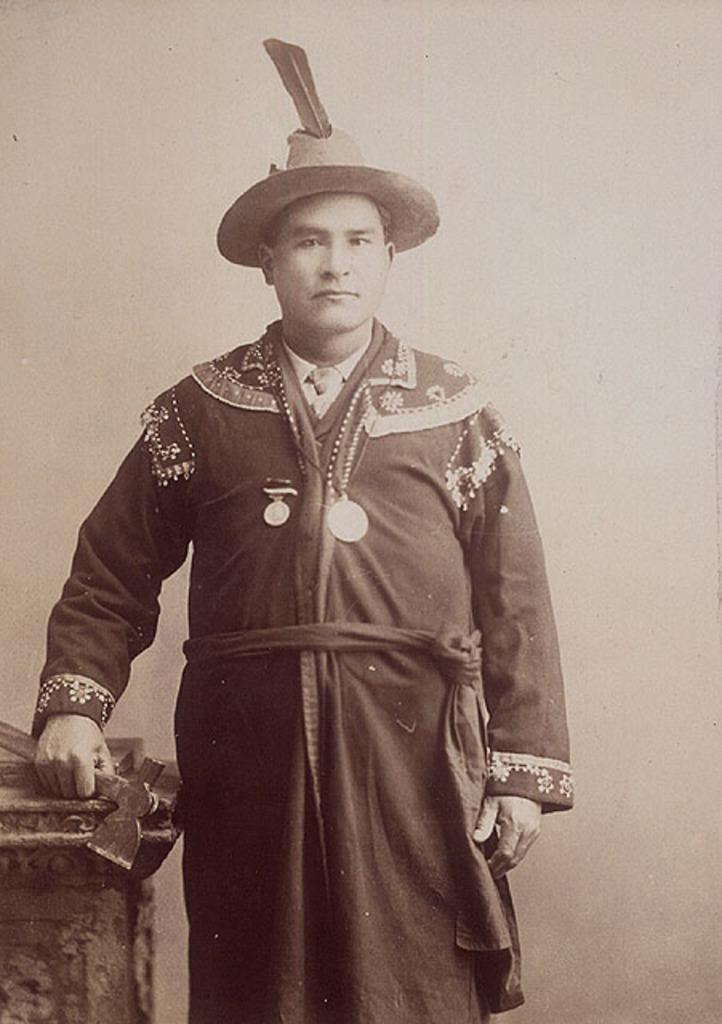What is the main subject of the image? There is a person standing in the image. What is the person holding in the image? The person is holding an object. What can be seen in the background of the image? There is a wall in the background of the image. What type of watch can be seen on the person's wrist in the image? There is no watch visible on the person's wrist in the image. 